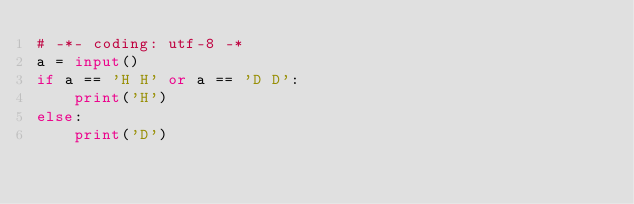<code> <loc_0><loc_0><loc_500><loc_500><_Python_># -*- coding: utf-8 -*
a = input()
if a == 'H H' or a == 'D D':
    print('H')
else:
    print('D')</code> 